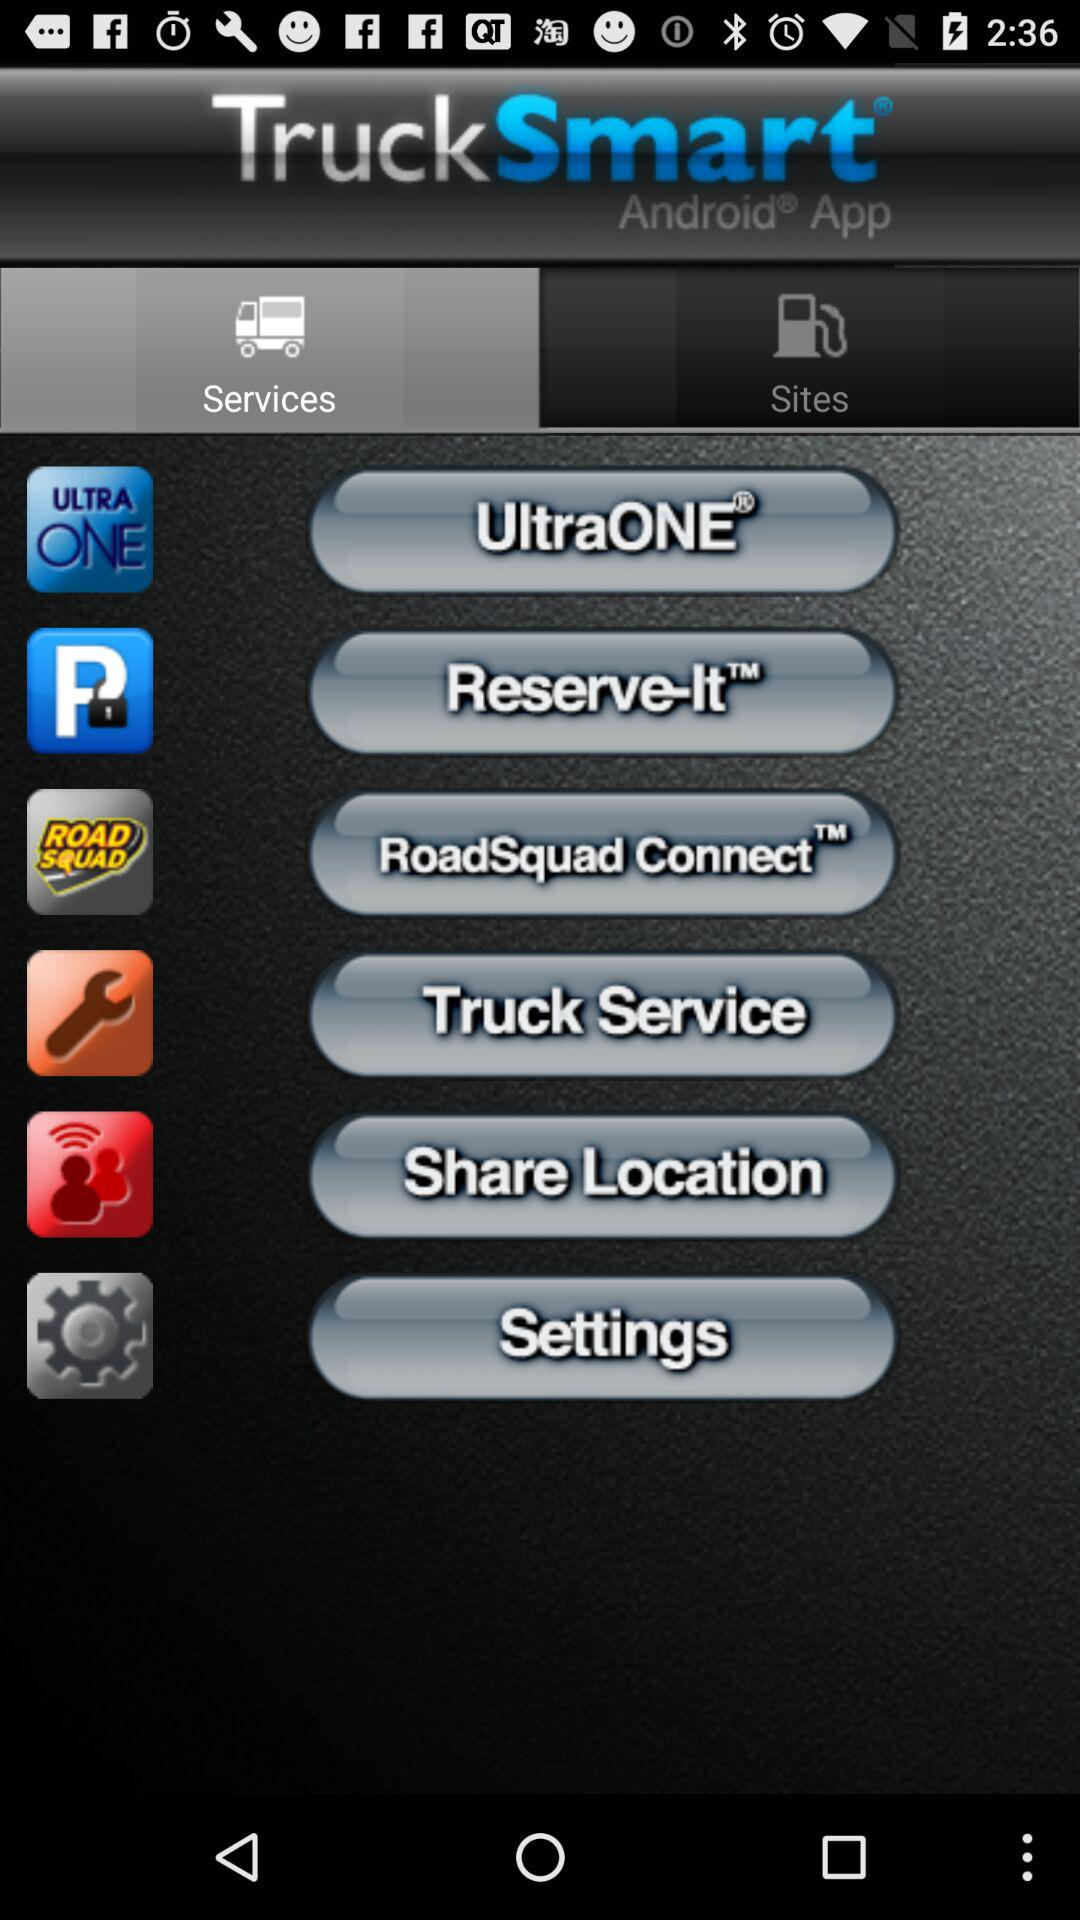Which applications are available for sharing the location?
When the provided information is insufficient, respond with <no answer>. <no answer> 